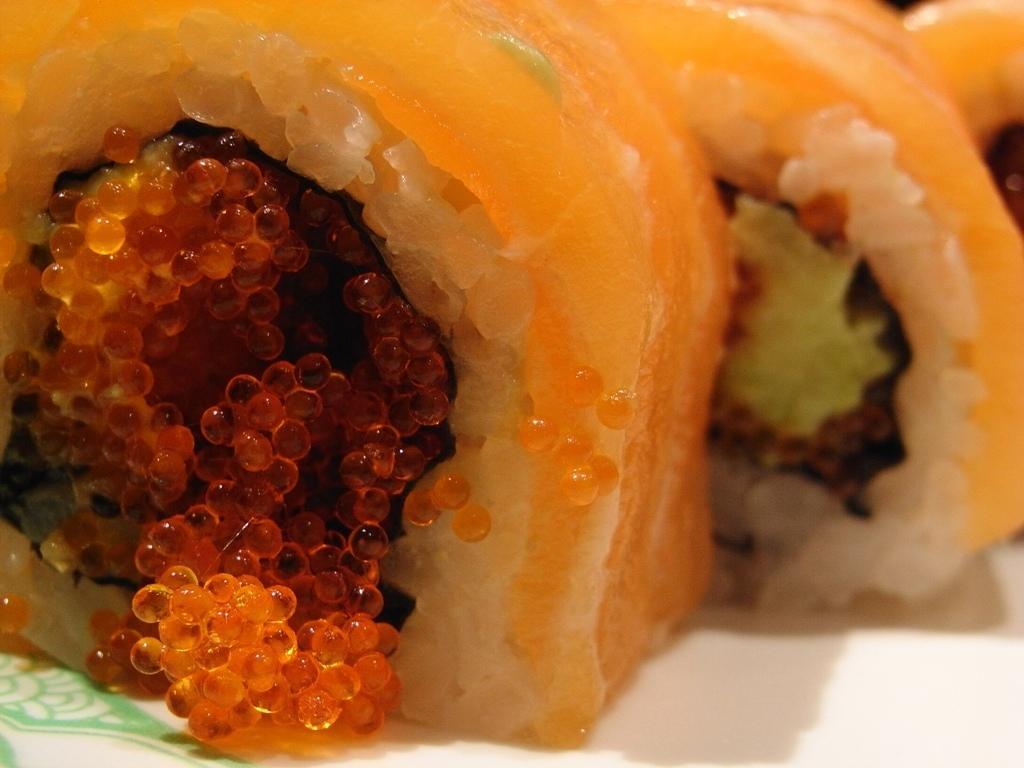Could you give a brief overview of what you see in this image? In this image, we can see food on the white surface. 